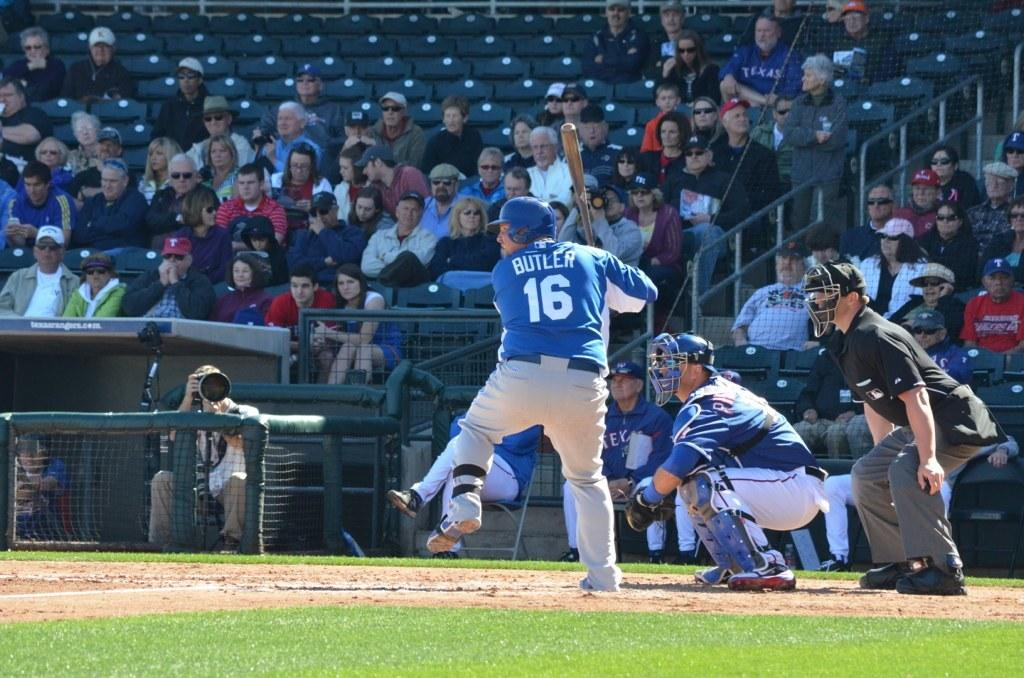<image>
Give a short and clear explanation of the subsequent image. Player number 16 named Butler gets ready to swing his bat 